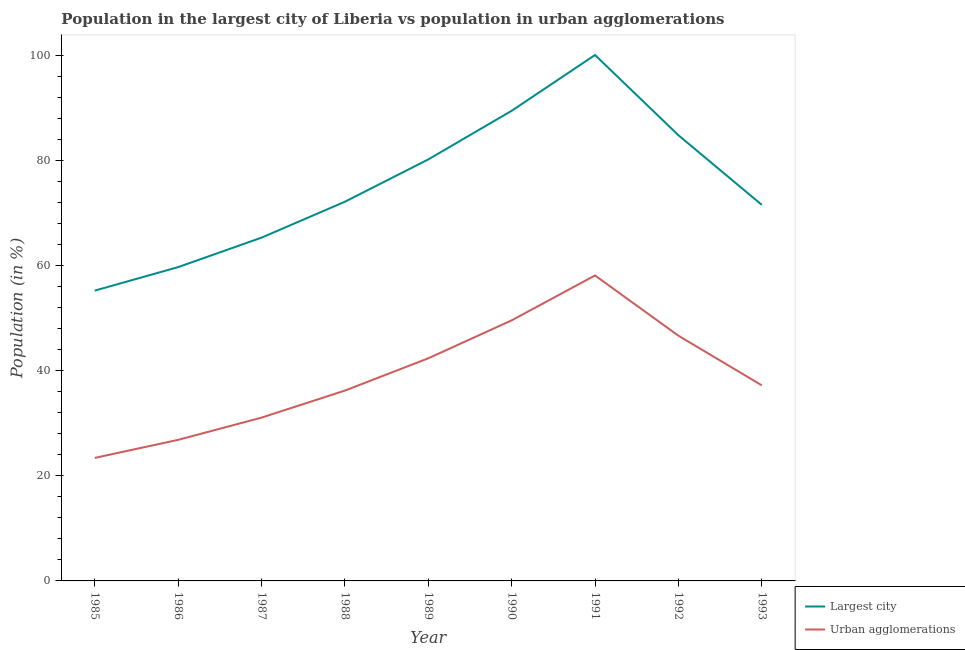What is the population in the largest city in 1990?
Your answer should be compact. 89.39. Across all years, what is the maximum population in urban agglomerations?
Your answer should be compact. 58.08. Across all years, what is the minimum population in urban agglomerations?
Offer a very short reply. 23.39. In which year was the population in the largest city minimum?
Make the answer very short. 1985. What is the total population in urban agglomerations in the graph?
Provide a short and direct response. 351.23. What is the difference between the population in the largest city in 1986 and that in 1990?
Your answer should be very brief. -29.73. What is the difference between the population in the largest city in 1991 and the population in urban agglomerations in 1987?
Offer a terse response. 68.95. What is the average population in the largest city per year?
Make the answer very short. 75.34. In the year 1988, what is the difference between the population in the largest city and population in urban agglomerations?
Your answer should be compact. 35.91. In how many years, is the population in urban agglomerations greater than 84 %?
Offer a very short reply. 0. What is the ratio of the population in the largest city in 1991 to that in 1992?
Provide a succinct answer. 1.18. What is the difference between the highest and the second highest population in urban agglomerations?
Give a very brief answer. 8.54. What is the difference between the highest and the lowest population in the largest city?
Provide a short and direct response. 44.8. Is the sum of the population in urban agglomerations in 1986 and 1991 greater than the maximum population in the largest city across all years?
Your answer should be compact. No. Is the population in the largest city strictly greater than the population in urban agglomerations over the years?
Your response must be concise. Yes. How many years are there in the graph?
Offer a very short reply. 9. How many legend labels are there?
Offer a very short reply. 2. What is the title of the graph?
Offer a very short reply. Population in the largest city of Liberia vs population in urban agglomerations. Does "Enforce a contract" appear as one of the legend labels in the graph?
Offer a terse response. No. What is the label or title of the X-axis?
Offer a very short reply. Year. What is the label or title of the Y-axis?
Make the answer very short. Population (in %). What is the Population (in %) of Largest city in 1985?
Offer a terse response. 55.2. What is the Population (in %) of Urban agglomerations in 1985?
Offer a very short reply. 23.39. What is the Population (in %) in Largest city in 1986?
Keep it short and to the point. 59.67. What is the Population (in %) in Urban agglomerations in 1986?
Provide a succinct answer. 26.83. What is the Population (in %) of Largest city in 1987?
Offer a very short reply. 65.27. What is the Population (in %) in Urban agglomerations in 1987?
Make the answer very short. 31.05. What is the Population (in %) in Largest city in 1988?
Your response must be concise. 72.1. What is the Population (in %) in Urban agglomerations in 1988?
Make the answer very short. 36.19. What is the Population (in %) of Largest city in 1989?
Keep it short and to the point. 80.15. What is the Population (in %) of Urban agglomerations in 1989?
Your answer should be compact. 42.33. What is the Population (in %) in Largest city in 1990?
Ensure brevity in your answer.  89.39. What is the Population (in %) of Urban agglomerations in 1990?
Give a very brief answer. 49.54. What is the Population (in %) in Largest city in 1991?
Give a very brief answer. 100. What is the Population (in %) of Urban agglomerations in 1991?
Your answer should be very brief. 58.08. What is the Population (in %) in Largest city in 1992?
Your answer should be compact. 84.75. What is the Population (in %) of Urban agglomerations in 1992?
Your answer should be compact. 46.63. What is the Population (in %) in Largest city in 1993?
Your answer should be compact. 71.51. What is the Population (in %) in Urban agglomerations in 1993?
Give a very brief answer. 37.19. Across all years, what is the maximum Population (in %) of Urban agglomerations?
Your answer should be compact. 58.08. Across all years, what is the minimum Population (in %) in Largest city?
Your response must be concise. 55.2. Across all years, what is the minimum Population (in %) in Urban agglomerations?
Offer a very short reply. 23.39. What is the total Population (in %) in Largest city in the graph?
Your answer should be very brief. 678.04. What is the total Population (in %) of Urban agglomerations in the graph?
Your response must be concise. 351.23. What is the difference between the Population (in %) of Largest city in 1985 and that in 1986?
Provide a succinct answer. -4.47. What is the difference between the Population (in %) in Urban agglomerations in 1985 and that in 1986?
Provide a short and direct response. -3.44. What is the difference between the Population (in %) of Largest city in 1985 and that in 1987?
Make the answer very short. -10.07. What is the difference between the Population (in %) in Urban agglomerations in 1985 and that in 1987?
Ensure brevity in your answer.  -7.66. What is the difference between the Population (in %) in Largest city in 1985 and that in 1988?
Your answer should be compact. -16.9. What is the difference between the Population (in %) of Urban agglomerations in 1985 and that in 1988?
Provide a short and direct response. -12.8. What is the difference between the Population (in %) of Largest city in 1985 and that in 1989?
Provide a short and direct response. -24.95. What is the difference between the Population (in %) of Urban agglomerations in 1985 and that in 1989?
Offer a very short reply. -18.94. What is the difference between the Population (in %) of Largest city in 1985 and that in 1990?
Your answer should be compact. -34.19. What is the difference between the Population (in %) in Urban agglomerations in 1985 and that in 1990?
Your answer should be compact. -26.15. What is the difference between the Population (in %) of Largest city in 1985 and that in 1991?
Provide a short and direct response. -44.8. What is the difference between the Population (in %) in Urban agglomerations in 1985 and that in 1991?
Your answer should be very brief. -34.69. What is the difference between the Population (in %) in Largest city in 1985 and that in 1992?
Provide a short and direct response. -29.55. What is the difference between the Population (in %) in Urban agglomerations in 1985 and that in 1992?
Make the answer very short. -23.24. What is the difference between the Population (in %) in Largest city in 1985 and that in 1993?
Offer a very short reply. -16.31. What is the difference between the Population (in %) in Urban agglomerations in 1985 and that in 1993?
Provide a succinct answer. -13.8. What is the difference between the Population (in %) in Largest city in 1986 and that in 1987?
Your response must be concise. -5.6. What is the difference between the Population (in %) of Urban agglomerations in 1986 and that in 1987?
Your answer should be very brief. -4.22. What is the difference between the Population (in %) of Largest city in 1986 and that in 1988?
Offer a terse response. -12.43. What is the difference between the Population (in %) in Urban agglomerations in 1986 and that in 1988?
Your answer should be very brief. -9.37. What is the difference between the Population (in %) of Largest city in 1986 and that in 1989?
Provide a short and direct response. -20.48. What is the difference between the Population (in %) in Urban agglomerations in 1986 and that in 1989?
Ensure brevity in your answer.  -15.5. What is the difference between the Population (in %) in Largest city in 1986 and that in 1990?
Offer a terse response. -29.73. What is the difference between the Population (in %) of Urban agglomerations in 1986 and that in 1990?
Keep it short and to the point. -22.72. What is the difference between the Population (in %) in Largest city in 1986 and that in 1991?
Your answer should be compact. -40.33. What is the difference between the Population (in %) of Urban agglomerations in 1986 and that in 1991?
Give a very brief answer. -31.26. What is the difference between the Population (in %) in Largest city in 1986 and that in 1992?
Make the answer very short. -25.08. What is the difference between the Population (in %) of Urban agglomerations in 1986 and that in 1992?
Offer a very short reply. -19.8. What is the difference between the Population (in %) in Largest city in 1986 and that in 1993?
Provide a short and direct response. -11.84. What is the difference between the Population (in %) of Urban agglomerations in 1986 and that in 1993?
Your response must be concise. -10.37. What is the difference between the Population (in %) of Largest city in 1987 and that in 1988?
Keep it short and to the point. -6.83. What is the difference between the Population (in %) of Urban agglomerations in 1987 and that in 1988?
Ensure brevity in your answer.  -5.14. What is the difference between the Population (in %) in Largest city in 1987 and that in 1989?
Keep it short and to the point. -14.88. What is the difference between the Population (in %) of Urban agglomerations in 1987 and that in 1989?
Keep it short and to the point. -11.28. What is the difference between the Population (in %) of Largest city in 1987 and that in 1990?
Ensure brevity in your answer.  -24.13. What is the difference between the Population (in %) of Urban agglomerations in 1987 and that in 1990?
Keep it short and to the point. -18.5. What is the difference between the Population (in %) in Largest city in 1987 and that in 1991?
Ensure brevity in your answer.  -34.73. What is the difference between the Population (in %) in Urban agglomerations in 1987 and that in 1991?
Offer a terse response. -27.03. What is the difference between the Population (in %) in Largest city in 1987 and that in 1992?
Provide a short and direct response. -19.48. What is the difference between the Population (in %) in Urban agglomerations in 1987 and that in 1992?
Give a very brief answer. -15.58. What is the difference between the Population (in %) in Largest city in 1987 and that in 1993?
Offer a very short reply. -6.24. What is the difference between the Population (in %) in Urban agglomerations in 1987 and that in 1993?
Give a very brief answer. -6.14. What is the difference between the Population (in %) of Largest city in 1988 and that in 1989?
Provide a succinct answer. -8.04. What is the difference between the Population (in %) in Urban agglomerations in 1988 and that in 1989?
Provide a short and direct response. -6.14. What is the difference between the Population (in %) of Largest city in 1988 and that in 1990?
Provide a succinct answer. -17.29. What is the difference between the Population (in %) of Urban agglomerations in 1988 and that in 1990?
Provide a succinct answer. -13.35. What is the difference between the Population (in %) of Largest city in 1988 and that in 1991?
Keep it short and to the point. -27.9. What is the difference between the Population (in %) in Urban agglomerations in 1988 and that in 1991?
Your response must be concise. -21.89. What is the difference between the Population (in %) of Largest city in 1988 and that in 1992?
Offer a terse response. -12.65. What is the difference between the Population (in %) in Urban agglomerations in 1988 and that in 1992?
Make the answer very short. -10.44. What is the difference between the Population (in %) of Largest city in 1988 and that in 1993?
Your answer should be compact. 0.59. What is the difference between the Population (in %) of Urban agglomerations in 1988 and that in 1993?
Offer a very short reply. -1. What is the difference between the Population (in %) of Largest city in 1989 and that in 1990?
Provide a short and direct response. -9.25. What is the difference between the Population (in %) of Urban agglomerations in 1989 and that in 1990?
Give a very brief answer. -7.22. What is the difference between the Population (in %) of Largest city in 1989 and that in 1991?
Your response must be concise. -19.85. What is the difference between the Population (in %) of Urban agglomerations in 1989 and that in 1991?
Your answer should be compact. -15.75. What is the difference between the Population (in %) of Largest city in 1989 and that in 1992?
Your answer should be very brief. -4.61. What is the difference between the Population (in %) of Urban agglomerations in 1989 and that in 1992?
Make the answer very short. -4.3. What is the difference between the Population (in %) in Largest city in 1989 and that in 1993?
Keep it short and to the point. 8.64. What is the difference between the Population (in %) of Urban agglomerations in 1989 and that in 1993?
Your response must be concise. 5.14. What is the difference between the Population (in %) in Largest city in 1990 and that in 1991?
Ensure brevity in your answer.  -10.61. What is the difference between the Population (in %) in Urban agglomerations in 1990 and that in 1991?
Provide a succinct answer. -8.54. What is the difference between the Population (in %) of Largest city in 1990 and that in 1992?
Offer a very short reply. 4.64. What is the difference between the Population (in %) of Urban agglomerations in 1990 and that in 1992?
Offer a terse response. 2.91. What is the difference between the Population (in %) of Largest city in 1990 and that in 1993?
Give a very brief answer. 17.89. What is the difference between the Population (in %) in Urban agglomerations in 1990 and that in 1993?
Provide a short and direct response. 12.35. What is the difference between the Population (in %) in Largest city in 1991 and that in 1992?
Your answer should be very brief. 15.25. What is the difference between the Population (in %) in Urban agglomerations in 1991 and that in 1992?
Your answer should be compact. 11.45. What is the difference between the Population (in %) in Largest city in 1991 and that in 1993?
Ensure brevity in your answer.  28.49. What is the difference between the Population (in %) of Urban agglomerations in 1991 and that in 1993?
Your answer should be compact. 20.89. What is the difference between the Population (in %) of Largest city in 1992 and that in 1993?
Keep it short and to the point. 13.24. What is the difference between the Population (in %) of Urban agglomerations in 1992 and that in 1993?
Ensure brevity in your answer.  9.44. What is the difference between the Population (in %) in Largest city in 1985 and the Population (in %) in Urban agglomerations in 1986?
Provide a short and direct response. 28.37. What is the difference between the Population (in %) in Largest city in 1985 and the Population (in %) in Urban agglomerations in 1987?
Offer a very short reply. 24.15. What is the difference between the Population (in %) of Largest city in 1985 and the Population (in %) of Urban agglomerations in 1988?
Ensure brevity in your answer.  19.01. What is the difference between the Population (in %) in Largest city in 1985 and the Population (in %) in Urban agglomerations in 1989?
Keep it short and to the point. 12.87. What is the difference between the Population (in %) in Largest city in 1985 and the Population (in %) in Urban agglomerations in 1990?
Ensure brevity in your answer.  5.66. What is the difference between the Population (in %) of Largest city in 1985 and the Population (in %) of Urban agglomerations in 1991?
Make the answer very short. -2.88. What is the difference between the Population (in %) in Largest city in 1985 and the Population (in %) in Urban agglomerations in 1992?
Provide a short and direct response. 8.57. What is the difference between the Population (in %) of Largest city in 1985 and the Population (in %) of Urban agglomerations in 1993?
Offer a very short reply. 18.01. What is the difference between the Population (in %) in Largest city in 1986 and the Population (in %) in Urban agglomerations in 1987?
Offer a very short reply. 28.62. What is the difference between the Population (in %) in Largest city in 1986 and the Population (in %) in Urban agglomerations in 1988?
Your answer should be compact. 23.48. What is the difference between the Population (in %) in Largest city in 1986 and the Population (in %) in Urban agglomerations in 1989?
Your response must be concise. 17.34. What is the difference between the Population (in %) of Largest city in 1986 and the Population (in %) of Urban agglomerations in 1990?
Ensure brevity in your answer.  10.13. What is the difference between the Population (in %) of Largest city in 1986 and the Population (in %) of Urban agglomerations in 1991?
Your response must be concise. 1.59. What is the difference between the Population (in %) of Largest city in 1986 and the Population (in %) of Urban agglomerations in 1992?
Your answer should be very brief. 13.04. What is the difference between the Population (in %) in Largest city in 1986 and the Population (in %) in Urban agglomerations in 1993?
Offer a terse response. 22.48. What is the difference between the Population (in %) of Largest city in 1987 and the Population (in %) of Urban agglomerations in 1988?
Offer a very short reply. 29.08. What is the difference between the Population (in %) in Largest city in 1987 and the Population (in %) in Urban agglomerations in 1989?
Your answer should be very brief. 22.94. What is the difference between the Population (in %) of Largest city in 1987 and the Population (in %) of Urban agglomerations in 1990?
Provide a short and direct response. 15.73. What is the difference between the Population (in %) of Largest city in 1987 and the Population (in %) of Urban agglomerations in 1991?
Offer a terse response. 7.19. What is the difference between the Population (in %) in Largest city in 1987 and the Population (in %) in Urban agglomerations in 1992?
Make the answer very short. 18.64. What is the difference between the Population (in %) in Largest city in 1987 and the Population (in %) in Urban agglomerations in 1993?
Keep it short and to the point. 28.08. What is the difference between the Population (in %) in Largest city in 1988 and the Population (in %) in Urban agglomerations in 1989?
Give a very brief answer. 29.77. What is the difference between the Population (in %) in Largest city in 1988 and the Population (in %) in Urban agglomerations in 1990?
Ensure brevity in your answer.  22.56. What is the difference between the Population (in %) in Largest city in 1988 and the Population (in %) in Urban agglomerations in 1991?
Provide a short and direct response. 14.02. What is the difference between the Population (in %) of Largest city in 1988 and the Population (in %) of Urban agglomerations in 1992?
Provide a succinct answer. 25.47. What is the difference between the Population (in %) of Largest city in 1988 and the Population (in %) of Urban agglomerations in 1993?
Provide a succinct answer. 34.91. What is the difference between the Population (in %) in Largest city in 1989 and the Population (in %) in Urban agglomerations in 1990?
Your answer should be very brief. 30.6. What is the difference between the Population (in %) in Largest city in 1989 and the Population (in %) in Urban agglomerations in 1991?
Offer a very short reply. 22.06. What is the difference between the Population (in %) in Largest city in 1989 and the Population (in %) in Urban agglomerations in 1992?
Make the answer very short. 33.52. What is the difference between the Population (in %) of Largest city in 1989 and the Population (in %) of Urban agglomerations in 1993?
Provide a short and direct response. 42.95. What is the difference between the Population (in %) of Largest city in 1990 and the Population (in %) of Urban agglomerations in 1991?
Offer a terse response. 31.31. What is the difference between the Population (in %) in Largest city in 1990 and the Population (in %) in Urban agglomerations in 1992?
Make the answer very short. 42.77. What is the difference between the Population (in %) in Largest city in 1990 and the Population (in %) in Urban agglomerations in 1993?
Your answer should be compact. 52.2. What is the difference between the Population (in %) of Largest city in 1991 and the Population (in %) of Urban agglomerations in 1992?
Your answer should be very brief. 53.37. What is the difference between the Population (in %) of Largest city in 1991 and the Population (in %) of Urban agglomerations in 1993?
Offer a very short reply. 62.81. What is the difference between the Population (in %) in Largest city in 1992 and the Population (in %) in Urban agglomerations in 1993?
Offer a very short reply. 47.56. What is the average Population (in %) of Largest city per year?
Offer a terse response. 75.34. What is the average Population (in %) in Urban agglomerations per year?
Provide a succinct answer. 39.03. In the year 1985, what is the difference between the Population (in %) of Largest city and Population (in %) of Urban agglomerations?
Keep it short and to the point. 31.81. In the year 1986, what is the difference between the Population (in %) of Largest city and Population (in %) of Urban agglomerations?
Your answer should be compact. 32.84. In the year 1987, what is the difference between the Population (in %) of Largest city and Population (in %) of Urban agglomerations?
Offer a very short reply. 34.22. In the year 1988, what is the difference between the Population (in %) in Largest city and Population (in %) in Urban agglomerations?
Give a very brief answer. 35.91. In the year 1989, what is the difference between the Population (in %) in Largest city and Population (in %) in Urban agglomerations?
Give a very brief answer. 37.82. In the year 1990, what is the difference between the Population (in %) in Largest city and Population (in %) in Urban agglomerations?
Make the answer very short. 39.85. In the year 1991, what is the difference between the Population (in %) in Largest city and Population (in %) in Urban agglomerations?
Provide a succinct answer. 41.92. In the year 1992, what is the difference between the Population (in %) in Largest city and Population (in %) in Urban agglomerations?
Give a very brief answer. 38.12. In the year 1993, what is the difference between the Population (in %) of Largest city and Population (in %) of Urban agglomerations?
Your answer should be very brief. 34.32. What is the ratio of the Population (in %) in Largest city in 1985 to that in 1986?
Offer a very short reply. 0.93. What is the ratio of the Population (in %) in Urban agglomerations in 1985 to that in 1986?
Provide a succinct answer. 0.87. What is the ratio of the Population (in %) in Largest city in 1985 to that in 1987?
Offer a terse response. 0.85. What is the ratio of the Population (in %) in Urban agglomerations in 1985 to that in 1987?
Your response must be concise. 0.75. What is the ratio of the Population (in %) of Largest city in 1985 to that in 1988?
Offer a very short reply. 0.77. What is the ratio of the Population (in %) of Urban agglomerations in 1985 to that in 1988?
Keep it short and to the point. 0.65. What is the ratio of the Population (in %) in Largest city in 1985 to that in 1989?
Ensure brevity in your answer.  0.69. What is the ratio of the Population (in %) of Urban agglomerations in 1985 to that in 1989?
Your response must be concise. 0.55. What is the ratio of the Population (in %) of Largest city in 1985 to that in 1990?
Provide a short and direct response. 0.62. What is the ratio of the Population (in %) of Urban agglomerations in 1985 to that in 1990?
Offer a very short reply. 0.47. What is the ratio of the Population (in %) in Largest city in 1985 to that in 1991?
Give a very brief answer. 0.55. What is the ratio of the Population (in %) of Urban agglomerations in 1985 to that in 1991?
Keep it short and to the point. 0.4. What is the ratio of the Population (in %) of Largest city in 1985 to that in 1992?
Ensure brevity in your answer.  0.65. What is the ratio of the Population (in %) of Urban agglomerations in 1985 to that in 1992?
Your answer should be very brief. 0.5. What is the ratio of the Population (in %) in Largest city in 1985 to that in 1993?
Provide a short and direct response. 0.77. What is the ratio of the Population (in %) in Urban agglomerations in 1985 to that in 1993?
Your response must be concise. 0.63. What is the ratio of the Population (in %) in Largest city in 1986 to that in 1987?
Your answer should be very brief. 0.91. What is the ratio of the Population (in %) of Urban agglomerations in 1986 to that in 1987?
Your response must be concise. 0.86. What is the ratio of the Population (in %) in Largest city in 1986 to that in 1988?
Keep it short and to the point. 0.83. What is the ratio of the Population (in %) in Urban agglomerations in 1986 to that in 1988?
Make the answer very short. 0.74. What is the ratio of the Population (in %) of Largest city in 1986 to that in 1989?
Give a very brief answer. 0.74. What is the ratio of the Population (in %) in Urban agglomerations in 1986 to that in 1989?
Your answer should be very brief. 0.63. What is the ratio of the Population (in %) in Largest city in 1986 to that in 1990?
Give a very brief answer. 0.67. What is the ratio of the Population (in %) in Urban agglomerations in 1986 to that in 1990?
Your answer should be compact. 0.54. What is the ratio of the Population (in %) of Largest city in 1986 to that in 1991?
Ensure brevity in your answer.  0.6. What is the ratio of the Population (in %) of Urban agglomerations in 1986 to that in 1991?
Make the answer very short. 0.46. What is the ratio of the Population (in %) in Largest city in 1986 to that in 1992?
Offer a terse response. 0.7. What is the ratio of the Population (in %) in Urban agglomerations in 1986 to that in 1992?
Ensure brevity in your answer.  0.58. What is the ratio of the Population (in %) of Largest city in 1986 to that in 1993?
Offer a very short reply. 0.83. What is the ratio of the Population (in %) of Urban agglomerations in 1986 to that in 1993?
Provide a succinct answer. 0.72. What is the ratio of the Population (in %) in Largest city in 1987 to that in 1988?
Provide a succinct answer. 0.91. What is the ratio of the Population (in %) of Urban agglomerations in 1987 to that in 1988?
Provide a short and direct response. 0.86. What is the ratio of the Population (in %) in Largest city in 1987 to that in 1989?
Provide a succinct answer. 0.81. What is the ratio of the Population (in %) in Urban agglomerations in 1987 to that in 1989?
Your answer should be compact. 0.73. What is the ratio of the Population (in %) in Largest city in 1987 to that in 1990?
Ensure brevity in your answer.  0.73. What is the ratio of the Population (in %) in Urban agglomerations in 1987 to that in 1990?
Your answer should be very brief. 0.63. What is the ratio of the Population (in %) of Largest city in 1987 to that in 1991?
Provide a succinct answer. 0.65. What is the ratio of the Population (in %) of Urban agglomerations in 1987 to that in 1991?
Provide a short and direct response. 0.53. What is the ratio of the Population (in %) of Largest city in 1987 to that in 1992?
Ensure brevity in your answer.  0.77. What is the ratio of the Population (in %) of Urban agglomerations in 1987 to that in 1992?
Your answer should be very brief. 0.67. What is the ratio of the Population (in %) of Largest city in 1987 to that in 1993?
Your answer should be compact. 0.91. What is the ratio of the Population (in %) of Urban agglomerations in 1987 to that in 1993?
Keep it short and to the point. 0.83. What is the ratio of the Population (in %) of Largest city in 1988 to that in 1989?
Provide a short and direct response. 0.9. What is the ratio of the Population (in %) of Urban agglomerations in 1988 to that in 1989?
Give a very brief answer. 0.85. What is the ratio of the Population (in %) of Largest city in 1988 to that in 1990?
Provide a succinct answer. 0.81. What is the ratio of the Population (in %) in Urban agglomerations in 1988 to that in 1990?
Keep it short and to the point. 0.73. What is the ratio of the Population (in %) of Largest city in 1988 to that in 1991?
Your response must be concise. 0.72. What is the ratio of the Population (in %) of Urban agglomerations in 1988 to that in 1991?
Keep it short and to the point. 0.62. What is the ratio of the Population (in %) in Largest city in 1988 to that in 1992?
Provide a short and direct response. 0.85. What is the ratio of the Population (in %) in Urban agglomerations in 1988 to that in 1992?
Offer a very short reply. 0.78. What is the ratio of the Population (in %) of Largest city in 1988 to that in 1993?
Your answer should be compact. 1.01. What is the ratio of the Population (in %) of Urban agglomerations in 1988 to that in 1993?
Give a very brief answer. 0.97. What is the ratio of the Population (in %) in Largest city in 1989 to that in 1990?
Ensure brevity in your answer.  0.9. What is the ratio of the Population (in %) in Urban agglomerations in 1989 to that in 1990?
Your response must be concise. 0.85. What is the ratio of the Population (in %) of Largest city in 1989 to that in 1991?
Offer a very short reply. 0.8. What is the ratio of the Population (in %) in Urban agglomerations in 1989 to that in 1991?
Ensure brevity in your answer.  0.73. What is the ratio of the Population (in %) in Largest city in 1989 to that in 1992?
Your answer should be compact. 0.95. What is the ratio of the Population (in %) of Urban agglomerations in 1989 to that in 1992?
Provide a short and direct response. 0.91. What is the ratio of the Population (in %) of Largest city in 1989 to that in 1993?
Provide a succinct answer. 1.12. What is the ratio of the Population (in %) of Urban agglomerations in 1989 to that in 1993?
Make the answer very short. 1.14. What is the ratio of the Population (in %) of Largest city in 1990 to that in 1991?
Your answer should be compact. 0.89. What is the ratio of the Population (in %) of Urban agglomerations in 1990 to that in 1991?
Provide a short and direct response. 0.85. What is the ratio of the Population (in %) in Largest city in 1990 to that in 1992?
Provide a succinct answer. 1.05. What is the ratio of the Population (in %) in Largest city in 1990 to that in 1993?
Provide a succinct answer. 1.25. What is the ratio of the Population (in %) in Urban agglomerations in 1990 to that in 1993?
Your response must be concise. 1.33. What is the ratio of the Population (in %) of Largest city in 1991 to that in 1992?
Keep it short and to the point. 1.18. What is the ratio of the Population (in %) in Urban agglomerations in 1991 to that in 1992?
Ensure brevity in your answer.  1.25. What is the ratio of the Population (in %) in Largest city in 1991 to that in 1993?
Offer a terse response. 1.4. What is the ratio of the Population (in %) in Urban agglomerations in 1991 to that in 1993?
Make the answer very short. 1.56. What is the ratio of the Population (in %) in Largest city in 1992 to that in 1993?
Keep it short and to the point. 1.19. What is the ratio of the Population (in %) of Urban agglomerations in 1992 to that in 1993?
Your answer should be compact. 1.25. What is the difference between the highest and the second highest Population (in %) in Largest city?
Offer a terse response. 10.61. What is the difference between the highest and the second highest Population (in %) in Urban agglomerations?
Provide a succinct answer. 8.54. What is the difference between the highest and the lowest Population (in %) in Largest city?
Make the answer very short. 44.8. What is the difference between the highest and the lowest Population (in %) in Urban agglomerations?
Your answer should be very brief. 34.69. 